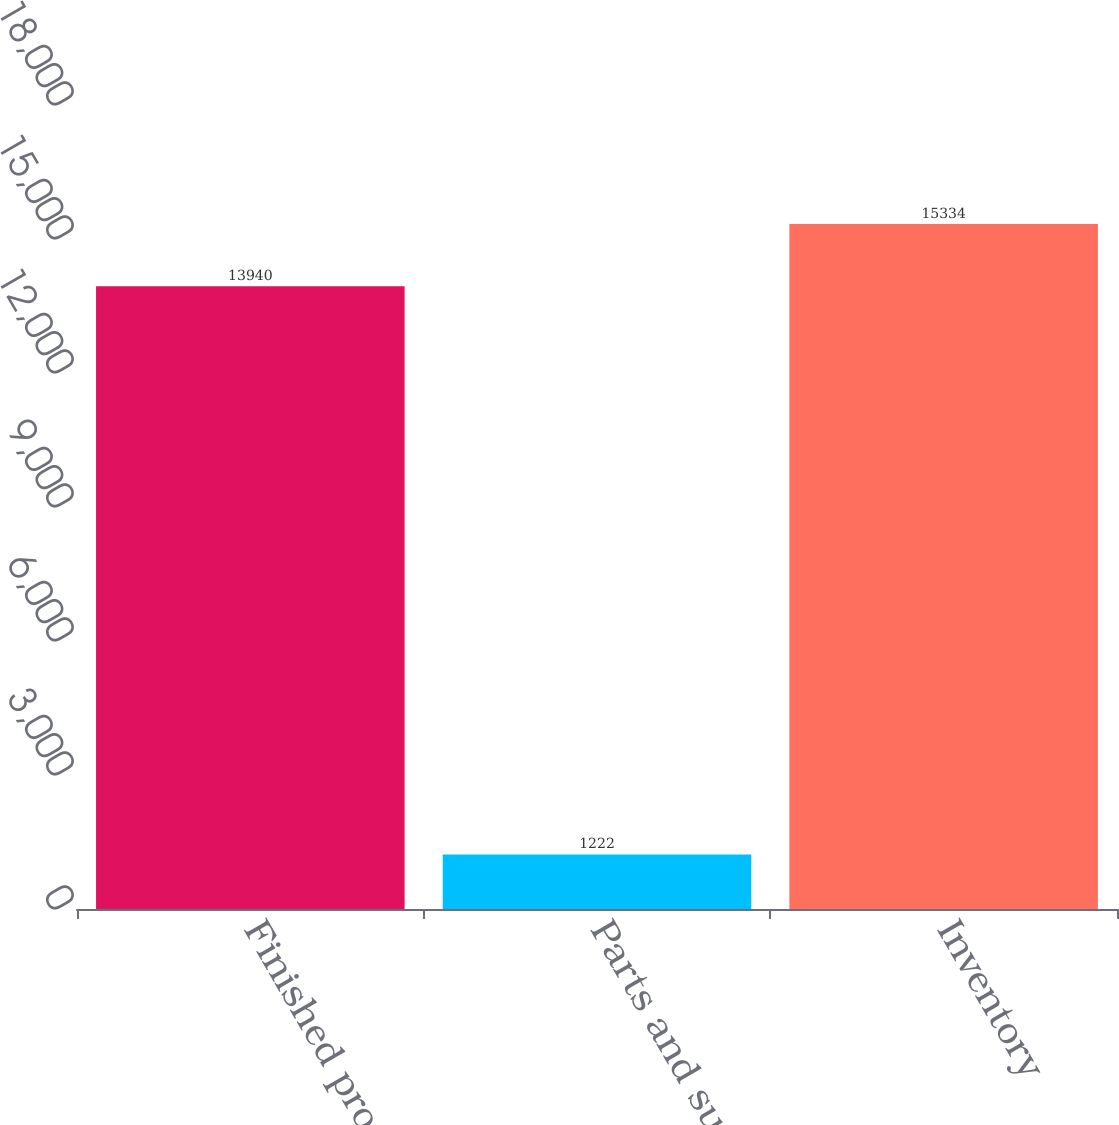<chart> <loc_0><loc_0><loc_500><loc_500><bar_chart><fcel>Finished products<fcel>Parts and supplies<fcel>Inventory<nl><fcel>13940<fcel>1222<fcel>15334<nl></chart> 